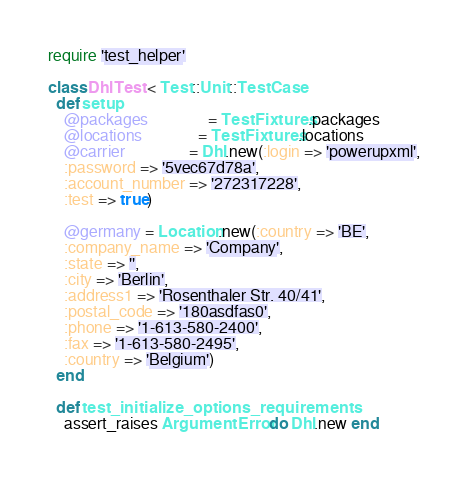<code> <loc_0><loc_0><loc_500><loc_500><_Ruby_>require 'test_helper'

class DhlTest < Test::Unit::TestCase
  def setup
    @packages               = TestFixtures.packages
    @locations              = TestFixtures.locations
    @carrier                = Dhl.new(:login => 'powerupxml',
    :password => '5vec67d78a',
    :account_number => '272317228',
    :test => true)

    @germany = Location.new(:country => 'BE',
    :company_name => 'Company',
    :state => '',
    :city => 'Berlin',
    :address1 => 'Rosenthaler Str. 40/41',
    :postal_code => '180asdfas0',
    :phone => '1-613-580-2400',
    :fax => '1-613-580-2495',
    :country => 'Belgium')
  end

  def test_initialize_options_requirements
    assert_raises ArgumentError do Dhl.new end</code> 